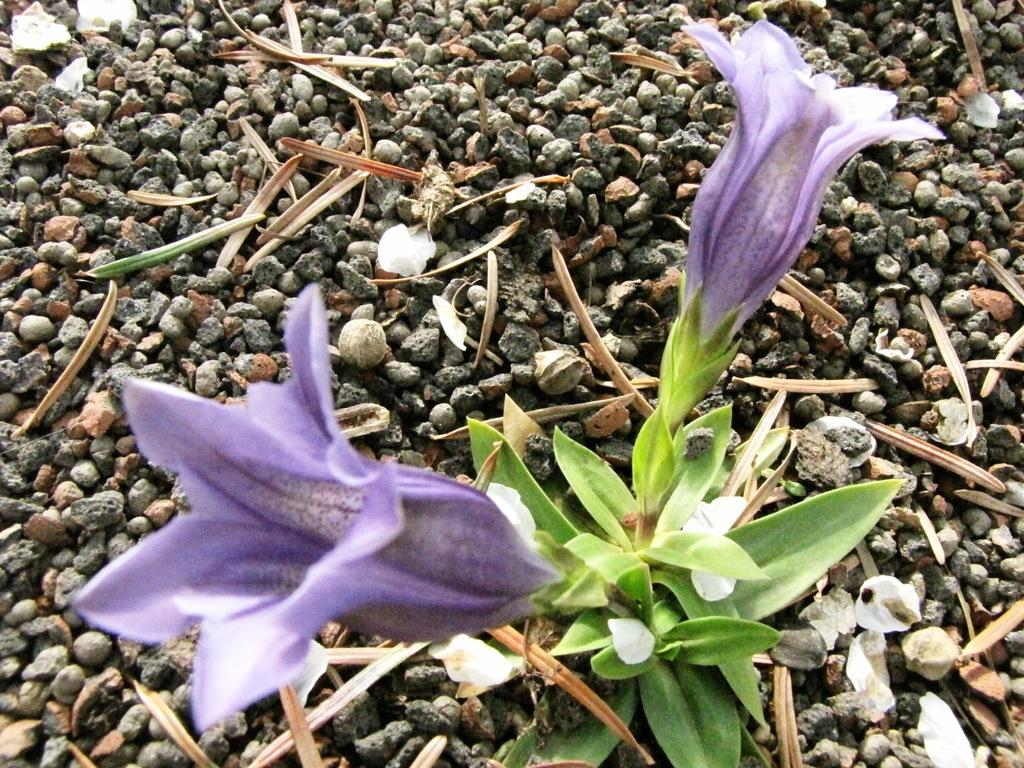How many flowers can be seen on the plant in the image? There are two flowers of the plant in the image. What else can be seen on the plant besides the flowers? There are leaves in the image. What other objects are present in the image besides the plant? Small stones are present in the image. What type of neck accessory is visible on the plant in the image? There is no neck accessory present on the plant in the image. How many snakes can be seen slithering around the plant in the image? There are no snakes present in the image; it only features a plant with flowers and leaves. 